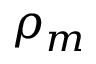Convert formula to latex. <formula><loc_0><loc_0><loc_500><loc_500>\rho _ { m }</formula> 